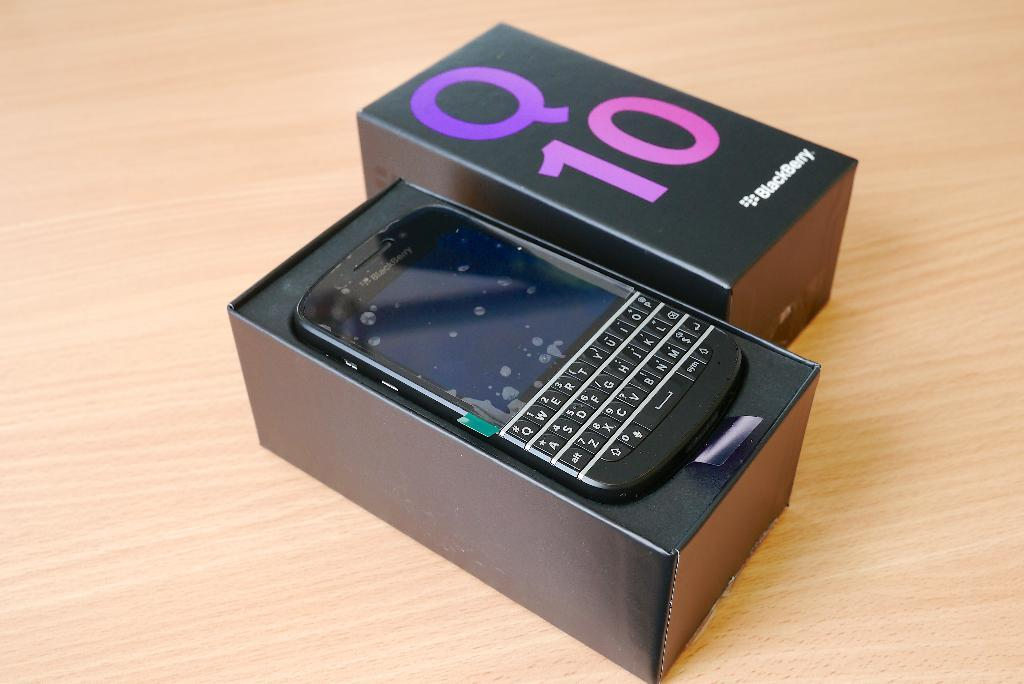<image>
Create a compact narrative representing the image presented. An open Blackberry box with a phone inside. 